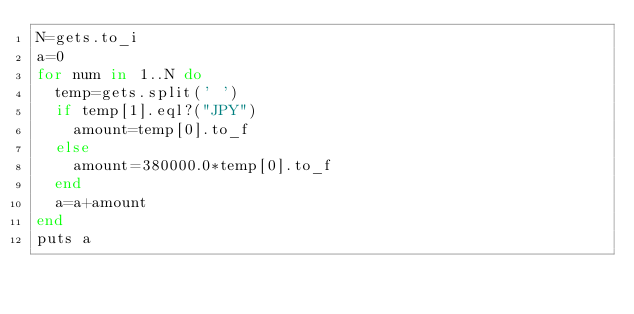<code> <loc_0><loc_0><loc_500><loc_500><_Ruby_>N=gets.to_i
a=0
for num in 1..N do
  temp=gets.split(' ')
  if temp[1].eql?("JPY")
    amount=temp[0].to_f
  else
    amount=380000.0*temp[0].to_f
  end
  a=a+amount
end
puts a</code> 